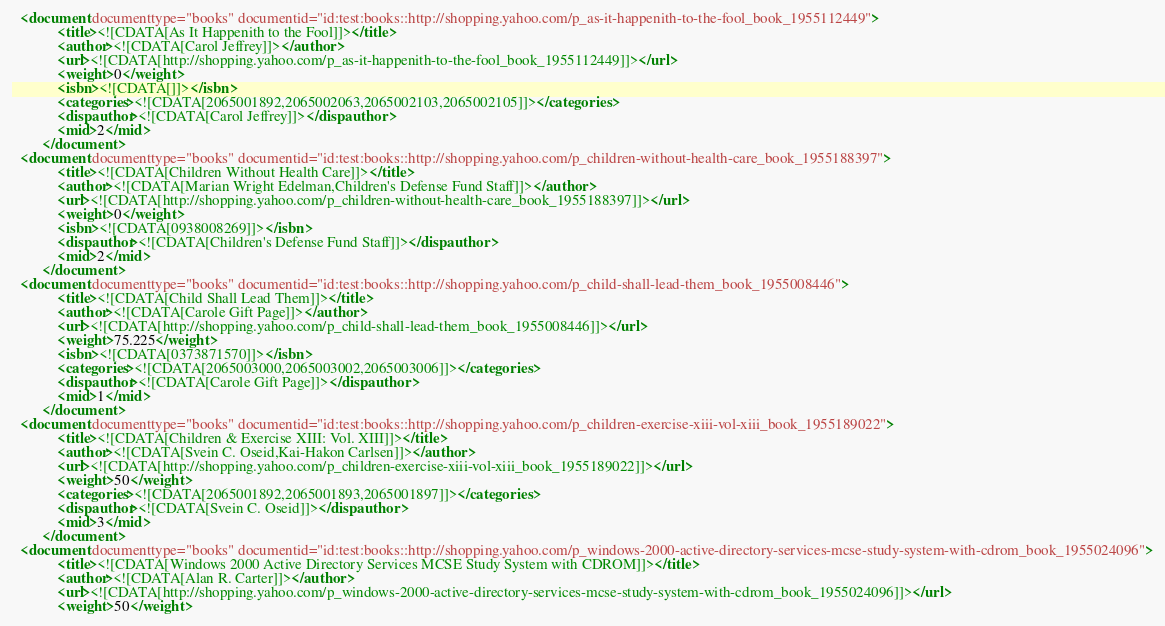<code> <loc_0><loc_0><loc_500><loc_500><_XML_>  <document documenttype="books" documentid="id:test:books::http://shopping.yahoo.com/p_as-it-happenith-to-the-fool_book_1955112449">
			<title><![CDATA[As It Happenith to the Fool]]></title>
			<author><![CDATA[Carol Jeffrey]]></author>
			<url><![CDATA[http://shopping.yahoo.com/p_as-it-happenith-to-the-fool_book_1955112449]]></url>
			<weight>0</weight>
			<isbn><![CDATA[]]></isbn>
			<categories><![CDATA[2065001892,2065002063,2065002103,2065002105]]></categories>
			<dispauthor><![CDATA[Carol Jeffrey]]></dispauthor>
			<mid>2</mid>
		</document>
  <document documenttype="books" documentid="id:test:books::http://shopping.yahoo.com/p_children-without-health-care_book_1955188397">
			<title><![CDATA[Children Without Health Care]]></title>
			<author><![CDATA[Marian Wright Edelman,Children's Defense Fund Staff]]></author>
			<url><![CDATA[http://shopping.yahoo.com/p_children-without-health-care_book_1955188397]]></url>
			<weight>0</weight>
			<isbn><![CDATA[0938008269]]></isbn>
			<dispauthor><![CDATA[Children's Defense Fund Staff]]></dispauthor>
			<mid>2</mid>
		</document>
  <document documenttype="books" documentid="id:test:books::http://shopping.yahoo.com/p_child-shall-lead-them_book_1955008446">
			<title><![CDATA[Child Shall Lead Them]]></title>
			<author><![CDATA[Carole Gift Page]]></author>
			<url><![CDATA[http://shopping.yahoo.com/p_child-shall-lead-them_book_1955008446]]></url>
			<weight>75.225</weight>
			<isbn><![CDATA[0373871570]]></isbn>
			<categories><![CDATA[2065003000,2065003002,2065003006]]></categories>
			<dispauthor><![CDATA[Carole Gift Page]]></dispauthor>
			<mid>1</mid>
		</document>
  <document documenttype="books" documentid="id:test:books::http://shopping.yahoo.com/p_children-exercise-xiii-vol-xiii_book_1955189022">
			<title><![CDATA[Children & Exercise XIII: Vol. XIII]]></title>
			<author><![CDATA[Svein C. Oseid,Kai-Hakon Carlsen]]></author>
			<url><![CDATA[http://shopping.yahoo.com/p_children-exercise-xiii-vol-xiii_book_1955189022]]></url>
			<weight>50</weight>
			<categories><![CDATA[2065001892,2065001893,2065001897]]></categories>
			<dispauthor><![CDATA[Svein C. Oseid]]></dispauthor>
			<mid>3</mid>
		</document>
  <document documenttype="books" documentid="id:test:books::http://shopping.yahoo.com/p_windows-2000-active-directory-services-mcse-study-system-with-cdrom_book_1955024096">
			<title><![CDATA[Windows 2000 Active Directory Services MCSE Study System with CDROM]]></title>
			<author><![CDATA[Alan R. Carter]]></author>
			<url><![CDATA[http://shopping.yahoo.com/p_windows-2000-active-directory-services-mcse-study-system-with-cdrom_book_1955024096]]></url>
			<weight>50</weight></code> 